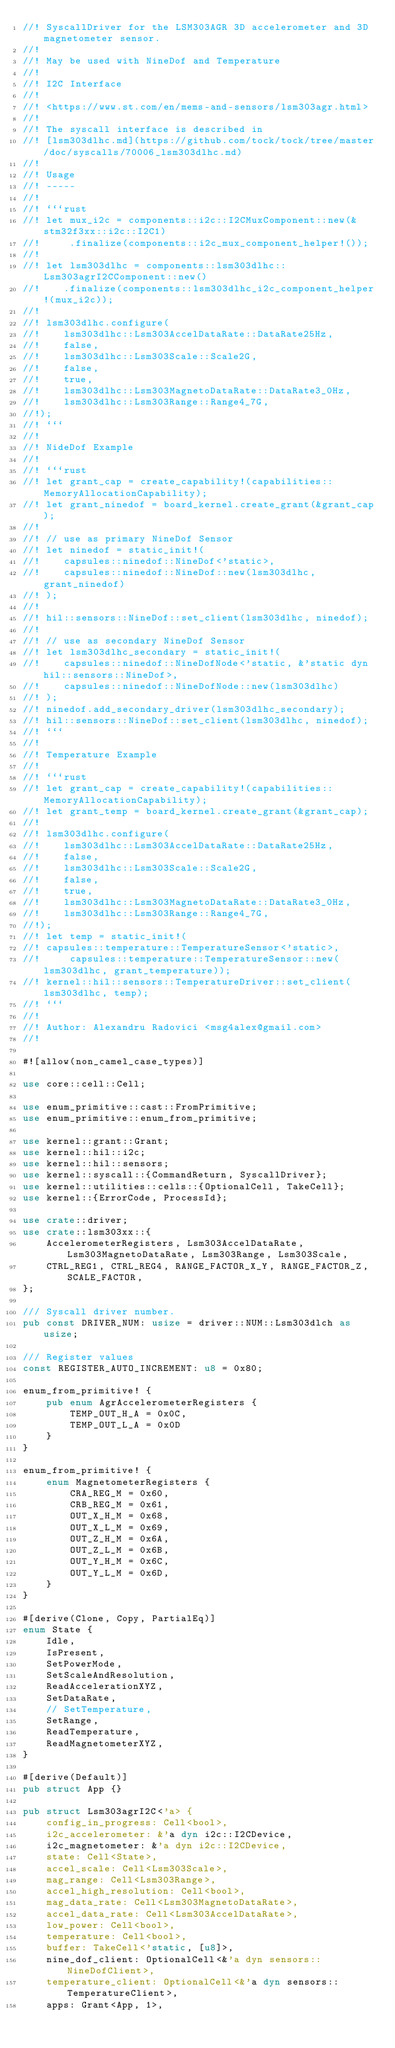Convert code to text. <code><loc_0><loc_0><loc_500><loc_500><_Rust_>//! SyscallDriver for the LSM303AGR 3D accelerometer and 3D magnetometer sensor.
//!
//! May be used with NineDof and Temperature
//!
//! I2C Interface
//!
//! <https://www.st.com/en/mems-and-sensors/lsm303agr.html>
//!
//! The syscall interface is described in
//! [lsm303dlhc.md](https://github.com/tock/tock/tree/master/doc/syscalls/70006_lsm303dlhc.md)
//!
//! Usage
//! -----
//!
//! ```rust
//! let mux_i2c = components::i2c::I2CMuxComponent::new(&stm32f3xx::i2c::I2C1)
//!     .finalize(components::i2c_mux_component_helper!());
//!
//! let lsm303dlhc = components::lsm303dlhc::Lsm303agrI2CComponent::new()
//!    .finalize(components::lsm303dlhc_i2c_component_helper!(mux_i2c));
//!
//! lsm303dlhc.configure(
//!    lsm303dlhc::Lsm303AccelDataRate::DataRate25Hz,
//!    false,
//!    lsm303dlhc::Lsm303Scale::Scale2G,
//!    false,
//!    true,
//!    lsm303dlhc::Lsm303MagnetoDataRate::DataRate3_0Hz,
//!    lsm303dlhc::Lsm303Range::Range4_7G,
//!);
//! ```
//!
//! NideDof Example
//!
//! ```rust
//! let grant_cap = create_capability!(capabilities::MemoryAllocationCapability);
//! let grant_ninedof = board_kernel.create_grant(&grant_cap);
//!
//! // use as primary NineDof Sensor
//! let ninedof = static_init!(
//!    capsules::ninedof::NineDof<'static>,
//!    capsules::ninedof::NineDof::new(lsm303dlhc, grant_ninedof)
//! );
//!
//! hil::sensors::NineDof::set_client(lsm303dlhc, ninedof);
//!
//! // use as secondary NineDof Sensor
//! let lsm303dlhc_secondary = static_init!(
//!    capsules::ninedof::NineDofNode<'static, &'static dyn hil::sensors::NineDof>,
//!    capsules::ninedof::NineDofNode::new(lsm303dlhc)
//! );
//! ninedof.add_secondary_driver(lsm303dlhc_secondary);
//! hil::sensors::NineDof::set_client(lsm303dlhc, ninedof);
//! ```
//!
//! Temperature Example
//!
//! ```rust
//! let grant_cap = create_capability!(capabilities::MemoryAllocationCapability);
//! let grant_temp = board_kernel.create_grant(&grant_cap);
//!
//! lsm303dlhc.configure(
//!    lsm303dlhc::Lsm303AccelDataRate::DataRate25Hz,
//!    false,
//!    lsm303dlhc::Lsm303Scale::Scale2G,
//!    false,
//!    true,
//!    lsm303dlhc::Lsm303MagnetoDataRate::DataRate3_0Hz,
//!    lsm303dlhc::Lsm303Range::Range4_7G,
//!);
//! let temp = static_init!(
//! capsules::temperature::TemperatureSensor<'static>,
//!     capsules::temperature::TemperatureSensor::new(lsm303dlhc, grant_temperature));
//! kernel::hil::sensors::TemperatureDriver::set_client(lsm303dlhc, temp);
//! ```
//!
//! Author: Alexandru Radovici <msg4alex@gmail.com>
//!

#![allow(non_camel_case_types)]

use core::cell::Cell;

use enum_primitive::cast::FromPrimitive;
use enum_primitive::enum_from_primitive;

use kernel::grant::Grant;
use kernel::hil::i2c;
use kernel::hil::sensors;
use kernel::syscall::{CommandReturn, SyscallDriver};
use kernel::utilities::cells::{OptionalCell, TakeCell};
use kernel::{ErrorCode, ProcessId};

use crate::driver;
use crate::lsm303xx::{
    AccelerometerRegisters, Lsm303AccelDataRate, Lsm303MagnetoDataRate, Lsm303Range, Lsm303Scale,
    CTRL_REG1, CTRL_REG4, RANGE_FACTOR_X_Y, RANGE_FACTOR_Z, SCALE_FACTOR,
};

/// Syscall driver number.
pub const DRIVER_NUM: usize = driver::NUM::Lsm303dlch as usize;

/// Register values
const REGISTER_AUTO_INCREMENT: u8 = 0x80;

enum_from_primitive! {
    pub enum AgrAccelerometerRegisters {
        TEMP_OUT_H_A = 0x0C,
        TEMP_OUT_L_A = 0x0D
    }
}

enum_from_primitive! {
    enum MagnetometerRegisters {
        CRA_REG_M = 0x60,
        CRB_REG_M = 0x61,
        OUT_X_H_M = 0x68,
        OUT_X_L_M = 0x69,
        OUT_Z_H_M = 0x6A,
        OUT_Z_L_M = 0x6B,
        OUT_Y_H_M = 0x6C,
        OUT_Y_L_M = 0x6D,
    }
}

#[derive(Clone, Copy, PartialEq)]
enum State {
    Idle,
    IsPresent,
    SetPowerMode,
    SetScaleAndResolution,
    ReadAccelerationXYZ,
    SetDataRate,
    // SetTemperature,
    SetRange,
    ReadTemperature,
    ReadMagnetometerXYZ,
}

#[derive(Default)]
pub struct App {}

pub struct Lsm303agrI2C<'a> {
    config_in_progress: Cell<bool>,
    i2c_accelerometer: &'a dyn i2c::I2CDevice,
    i2c_magnetometer: &'a dyn i2c::I2CDevice,
    state: Cell<State>,
    accel_scale: Cell<Lsm303Scale>,
    mag_range: Cell<Lsm303Range>,
    accel_high_resolution: Cell<bool>,
    mag_data_rate: Cell<Lsm303MagnetoDataRate>,
    accel_data_rate: Cell<Lsm303AccelDataRate>,
    low_power: Cell<bool>,
    temperature: Cell<bool>,
    buffer: TakeCell<'static, [u8]>,
    nine_dof_client: OptionalCell<&'a dyn sensors::NineDofClient>,
    temperature_client: OptionalCell<&'a dyn sensors::TemperatureClient>,
    apps: Grant<App, 1>,</code> 